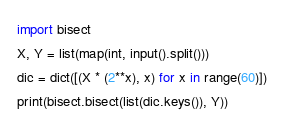<code> <loc_0><loc_0><loc_500><loc_500><_Python_>import bisect
X, Y = list(map(int, input().split()))
dic = dict([(X * (2**x), x) for x in range(60)])
print(bisect.bisect(list(dic.keys()), Y))
</code> 